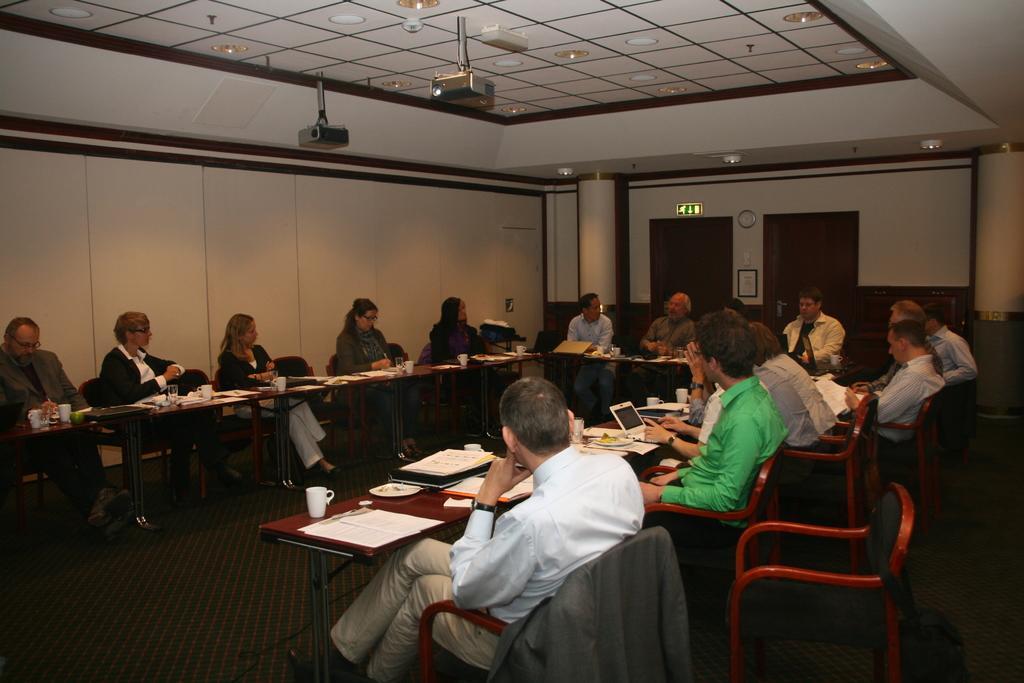In one or two sentences, can you explain what this image depicts? In this picture we can see some persons are sitting on the chairs. This is the table. On the table there is a cup, paper, book, and a laptop. This is the floor and there is a wall. Here we can see projectors. On the background we can see doors. And these are the lights. 